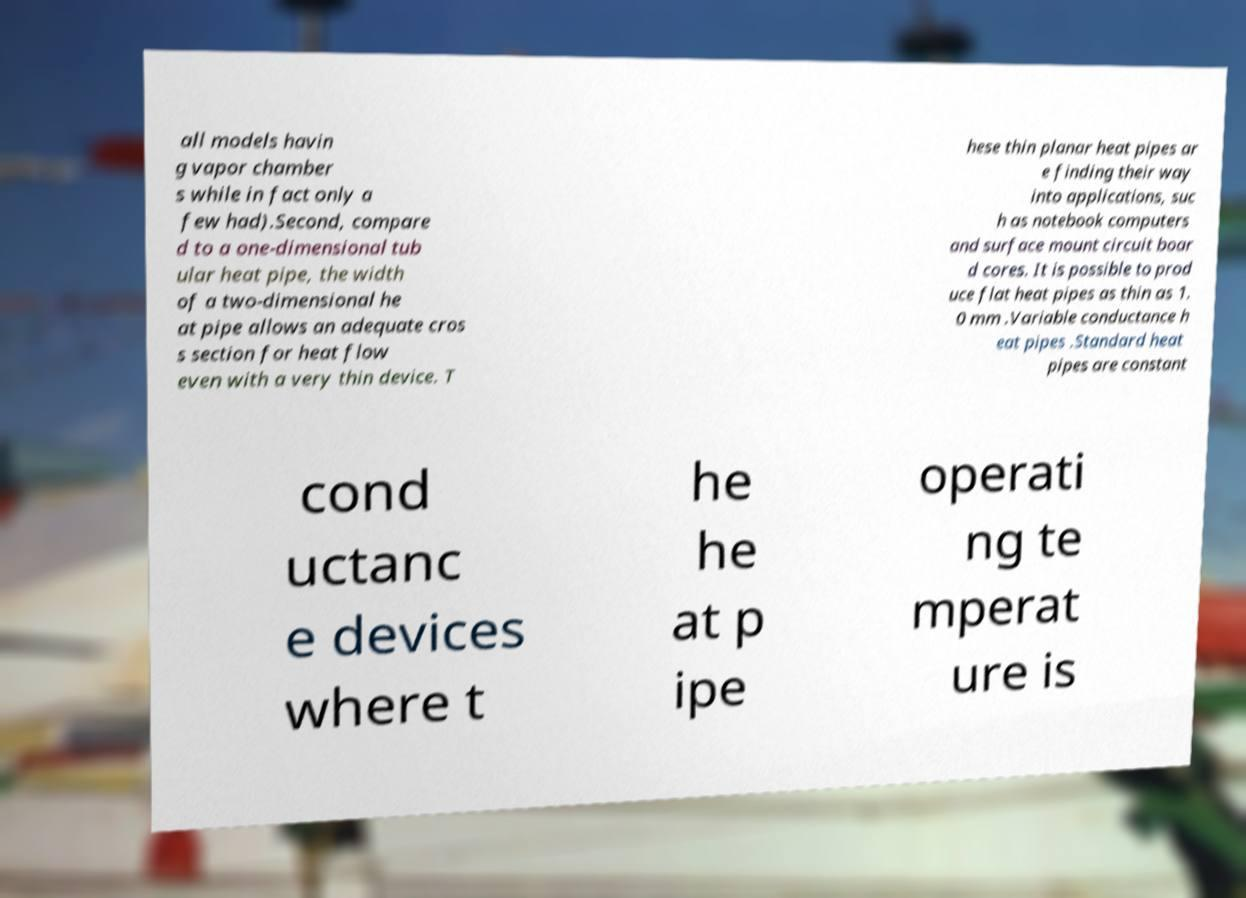What messages or text are displayed in this image? I need them in a readable, typed format. all models havin g vapor chamber s while in fact only a few had).Second, compare d to a one-dimensional tub ular heat pipe, the width of a two-dimensional he at pipe allows an adequate cros s section for heat flow even with a very thin device. T hese thin planar heat pipes ar e finding their way into applications, suc h as notebook computers and surface mount circuit boar d cores. It is possible to prod uce flat heat pipes as thin as 1. 0 mm .Variable conductance h eat pipes .Standard heat pipes are constant cond uctanc e devices where t he he at p ipe operati ng te mperat ure is 